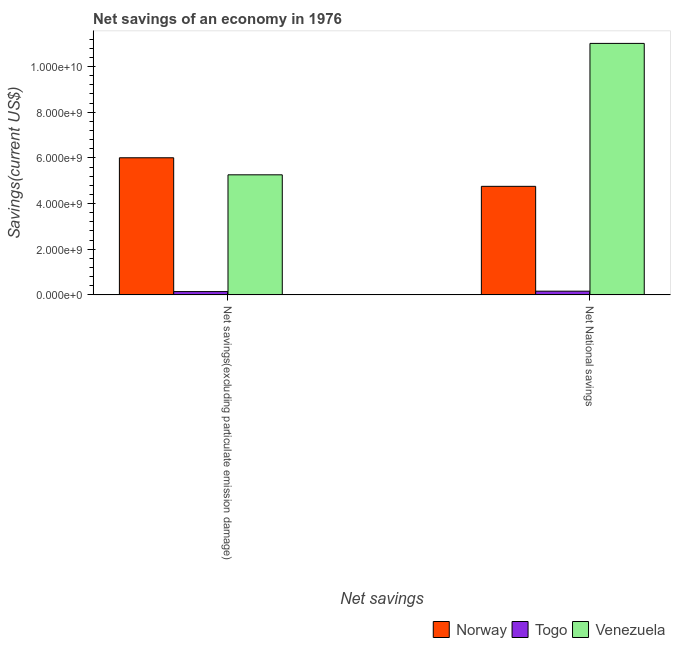How many different coloured bars are there?
Ensure brevity in your answer.  3. How many groups of bars are there?
Make the answer very short. 2. Are the number of bars per tick equal to the number of legend labels?
Ensure brevity in your answer.  Yes. How many bars are there on the 1st tick from the left?
Provide a succinct answer. 3. What is the label of the 2nd group of bars from the left?
Provide a short and direct response. Net National savings. What is the net national savings in Norway?
Your answer should be compact. 4.75e+09. Across all countries, what is the maximum net national savings?
Keep it short and to the point. 1.10e+1. Across all countries, what is the minimum net savings(excluding particulate emission damage)?
Offer a terse response. 1.45e+08. In which country was the net national savings minimum?
Your answer should be very brief. Togo. What is the total net national savings in the graph?
Ensure brevity in your answer.  1.59e+1. What is the difference between the net savings(excluding particulate emission damage) in Venezuela and that in Togo?
Provide a short and direct response. 5.11e+09. What is the difference between the net national savings in Venezuela and the net savings(excluding particulate emission damage) in Togo?
Offer a very short reply. 1.09e+1. What is the average net national savings per country?
Ensure brevity in your answer.  5.31e+09. What is the difference between the net national savings and net savings(excluding particulate emission damage) in Norway?
Your response must be concise. -1.25e+09. In how many countries, is the net savings(excluding particulate emission damage) greater than 7600000000 US$?
Your answer should be very brief. 0. What is the ratio of the net savings(excluding particulate emission damage) in Venezuela to that in Norway?
Your answer should be compact. 0.88. What does the 2nd bar from the right in Net National savings represents?
Offer a terse response. Togo. Are all the bars in the graph horizontal?
Ensure brevity in your answer.  No. How many countries are there in the graph?
Keep it short and to the point. 3. What is the difference between two consecutive major ticks on the Y-axis?
Keep it short and to the point. 2.00e+09. What is the title of the graph?
Give a very brief answer. Net savings of an economy in 1976. Does "Guinea-Bissau" appear as one of the legend labels in the graph?
Provide a short and direct response. No. What is the label or title of the X-axis?
Your answer should be very brief. Net savings. What is the label or title of the Y-axis?
Provide a succinct answer. Savings(current US$). What is the Savings(current US$) of Norway in Net savings(excluding particulate emission damage)?
Your answer should be very brief. 6.00e+09. What is the Savings(current US$) of Togo in Net savings(excluding particulate emission damage)?
Provide a succinct answer. 1.45e+08. What is the Savings(current US$) of Venezuela in Net savings(excluding particulate emission damage)?
Offer a terse response. 5.26e+09. What is the Savings(current US$) of Norway in Net National savings?
Provide a short and direct response. 4.75e+09. What is the Savings(current US$) of Togo in Net National savings?
Make the answer very short. 1.63e+08. What is the Savings(current US$) of Venezuela in Net National savings?
Make the answer very short. 1.10e+1. Across all Net savings, what is the maximum Savings(current US$) of Norway?
Make the answer very short. 6.00e+09. Across all Net savings, what is the maximum Savings(current US$) in Togo?
Keep it short and to the point. 1.63e+08. Across all Net savings, what is the maximum Savings(current US$) of Venezuela?
Offer a terse response. 1.10e+1. Across all Net savings, what is the minimum Savings(current US$) in Norway?
Your answer should be very brief. 4.75e+09. Across all Net savings, what is the minimum Savings(current US$) in Togo?
Your answer should be compact. 1.45e+08. Across all Net savings, what is the minimum Savings(current US$) in Venezuela?
Provide a succinct answer. 5.26e+09. What is the total Savings(current US$) in Norway in the graph?
Provide a short and direct response. 1.08e+1. What is the total Savings(current US$) of Togo in the graph?
Keep it short and to the point. 3.08e+08. What is the total Savings(current US$) of Venezuela in the graph?
Offer a very short reply. 1.63e+1. What is the difference between the Savings(current US$) of Norway in Net savings(excluding particulate emission damage) and that in Net National savings?
Your answer should be compact. 1.25e+09. What is the difference between the Savings(current US$) of Togo in Net savings(excluding particulate emission damage) and that in Net National savings?
Provide a succinct answer. -1.79e+07. What is the difference between the Savings(current US$) of Venezuela in Net savings(excluding particulate emission damage) and that in Net National savings?
Your answer should be compact. -5.76e+09. What is the difference between the Savings(current US$) in Norway in Net savings(excluding particulate emission damage) and the Savings(current US$) in Togo in Net National savings?
Your answer should be compact. 5.84e+09. What is the difference between the Savings(current US$) in Norway in Net savings(excluding particulate emission damage) and the Savings(current US$) in Venezuela in Net National savings?
Make the answer very short. -5.01e+09. What is the difference between the Savings(current US$) of Togo in Net savings(excluding particulate emission damage) and the Savings(current US$) of Venezuela in Net National savings?
Your response must be concise. -1.09e+1. What is the average Savings(current US$) in Norway per Net savings?
Ensure brevity in your answer.  5.38e+09. What is the average Savings(current US$) in Togo per Net savings?
Ensure brevity in your answer.  1.54e+08. What is the average Savings(current US$) in Venezuela per Net savings?
Your response must be concise. 8.14e+09. What is the difference between the Savings(current US$) in Norway and Savings(current US$) in Togo in Net savings(excluding particulate emission damage)?
Your response must be concise. 5.86e+09. What is the difference between the Savings(current US$) in Norway and Savings(current US$) in Venezuela in Net savings(excluding particulate emission damage)?
Offer a very short reply. 7.46e+08. What is the difference between the Savings(current US$) of Togo and Savings(current US$) of Venezuela in Net savings(excluding particulate emission damage)?
Your response must be concise. -5.11e+09. What is the difference between the Savings(current US$) in Norway and Savings(current US$) in Togo in Net National savings?
Offer a terse response. 4.59e+09. What is the difference between the Savings(current US$) in Norway and Savings(current US$) in Venezuela in Net National savings?
Your answer should be compact. -6.26e+09. What is the difference between the Savings(current US$) of Togo and Savings(current US$) of Venezuela in Net National savings?
Make the answer very short. -1.09e+1. What is the ratio of the Savings(current US$) of Norway in Net savings(excluding particulate emission damage) to that in Net National savings?
Ensure brevity in your answer.  1.26. What is the ratio of the Savings(current US$) of Togo in Net savings(excluding particulate emission damage) to that in Net National savings?
Your answer should be compact. 0.89. What is the ratio of the Savings(current US$) of Venezuela in Net savings(excluding particulate emission damage) to that in Net National savings?
Offer a very short reply. 0.48. What is the difference between the highest and the second highest Savings(current US$) of Norway?
Your response must be concise. 1.25e+09. What is the difference between the highest and the second highest Savings(current US$) in Togo?
Your response must be concise. 1.79e+07. What is the difference between the highest and the second highest Savings(current US$) in Venezuela?
Your answer should be very brief. 5.76e+09. What is the difference between the highest and the lowest Savings(current US$) of Norway?
Offer a very short reply. 1.25e+09. What is the difference between the highest and the lowest Savings(current US$) of Togo?
Provide a short and direct response. 1.79e+07. What is the difference between the highest and the lowest Savings(current US$) of Venezuela?
Make the answer very short. 5.76e+09. 